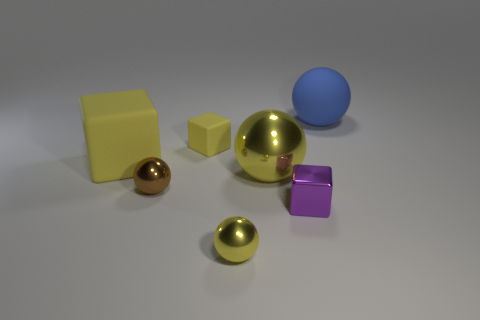There is a tiny rubber object; does it have the same color as the shiny thing that is on the left side of the tiny yellow sphere?
Your answer should be compact. No. What is the material of the large yellow thing that is to the left of the small yellow block?
Provide a succinct answer. Rubber. Are there any large shiny objects of the same color as the big rubber sphere?
Offer a terse response. No. There is a rubber cube that is the same size as the brown ball; what color is it?
Provide a succinct answer. Yellow. What number of tiny things are brown metal spheres or shiny things?
Offer a very short reply. 3. Are there the same number of brown spheres in front of the purple cube and shiny things to the right of the large yellow metallic ball?
Give a very brief answer. No. How many brown objects have the same size as the purple cube?
Ensure brevity in your answer.  1. What number of yellow things are matte cubes or tiny metal spheres?
Make the answer very short. 3. Are there the same number of large yellow cubes in front of the tiny yellow ball and shiny cubes?
Keep it short and to the point. No. There is a ball right of the purple metal block; how big is it?
Your answer should be compact. Large. 